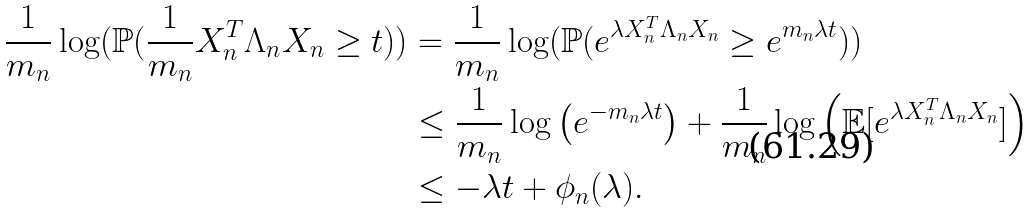<formula> <loc_0><loc_0><loc_500><loc_500>\frac { 1 } { m _ { n } } \log ( \mathbb { P } ( \frac { 1 } { m _ { n } } X _ { n } ^ { T } \Lambda _ { n } X _ { n } \geq t ) ) & = \frac { 1 } { m _ { n } } \log ( \mathbb { P } ( e ^ { \lambda X _ { n } ^ { T } \Lambda _ { n } X _ { n } } \geq e ^ { m _ { n } \lambda t } ) ) \\ & \leq \frac { 1 } { m _ { n } } \log \left ( e ^ { - m _ { n } \lambda t } \right ) + \frac { 1 } { m _ { n } } \log \left ( \mathbb { E } [ e ^ { \lambda X _ { n } ^ { T } \Lambda _ { n } X _ { n } } ] \right ) \\ & \leq - \lambda t + \phi _ { n } ( \lambda ) .</formula> 